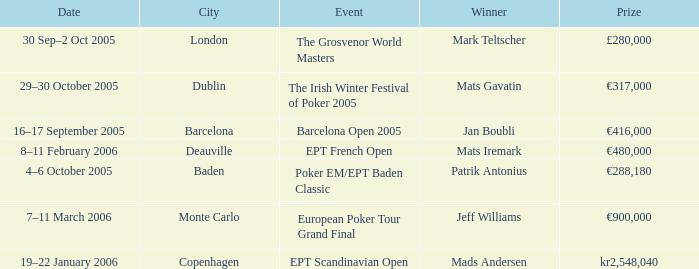What event had a prize of €900,000? European Poker Tour Grand Final. 